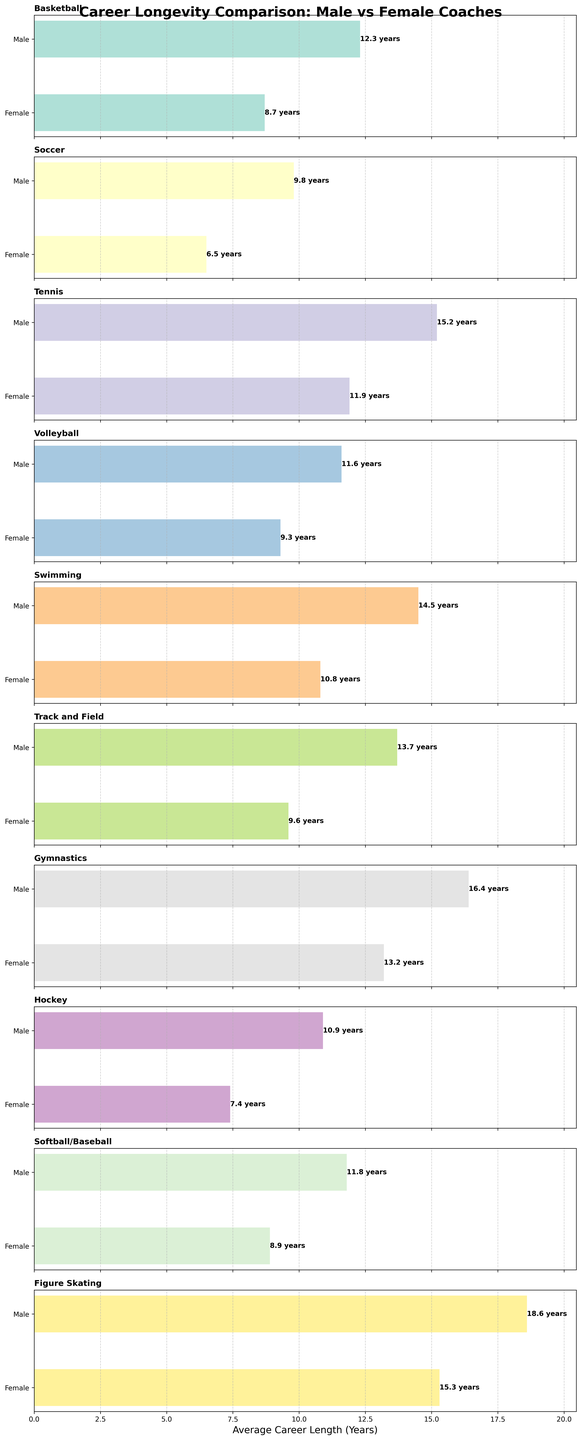Which sport shows the greatest difference in average career length between male and female coaches? Observe the horizontal bars for each sport and identify which one has the largest gap between the 'Male' and 'Female' bars. Gymnastics has the largest difference, 16.4 years (male) and 13.2 years (female), which is a difference of 3.2 years.
Answer: Gymnastics Which sport has the shortest average career length for female coaches? Look at the horizontal bar for female coaches in each subplot and identify the one with the shortest length. Soccer's female coaches have an average career length of 6.5 years, which is the shortest among all sports.
Answer: Soccer Which sport has the longest average career length for male coaches, and what is that length? Identify the longest horizontal bar for male coaches across all subplots. Figure Skating has the longest bar for male coaches with a length of 18.6 years.
Answer: Figure Skating, 18.6 years What is the average career length difference for basketball coaches between males and females? Subtract the average career length of female basketball coaches from that of male basketball coaches. The difference is 12.3 - 8.7 = 3.6 years.
Answer: 3.6 years How does the average career length of male tennis coaches compare to female tennis coaches? Compare the lengths of the horizontal bars for male and female coaches in the tennis subplot. Male tennis coaches have a career length of 15.2 years, while female tennis coaches have 11.9 years, so males have longer careers.
Answer: Male tennis coaches have longer careers In which sport are the average career lengths of male and female coaches the most similar? Find the sport with the smallest difference between the lengths of the male and female horizontal bars. For Tennis, male coaches have an average career of 15.2 years and female coaches have 11.9 years, giving a difference of 3.3 years, which is the smallest among the given sports.
Answer: Tennis What is the difference in average career length between male and female volleyball coaches, and how does it compare to the difference in hockey coaches? Calculate the differences: Volleyball is 11.6 - 9.3 = 2.3 years, and Hockey is 10.9 - 7.4 = 3.5 years. Compare these two differences; Volleyball's difference is smaller.
Answer: Volleyball: 2.3 years, Hockey: 3.5 years Which sport shows a greater discrepancy in the average career lengths of male and female coaches: Swimming or Track and Field? Calculate the differences for both sports: Swimming has 14.5 (male) vs 10.8 (female), which is 3.7 years. Track and Field has 13.7 (male) vs 9.6 (female), which is 4.1 years. Track and Field has a greater discrepancy.
Answer: Track and Field Do male or female volleyball coaches have longer career lengths in their sport? Compare the lengths of the horizontal bars for male and female volleyball coaches. Male volleyball coaches have an average career length of 11.6 years, while females have 9.3 years. Males have longer careers.
Answer: Male volleyball coaches 